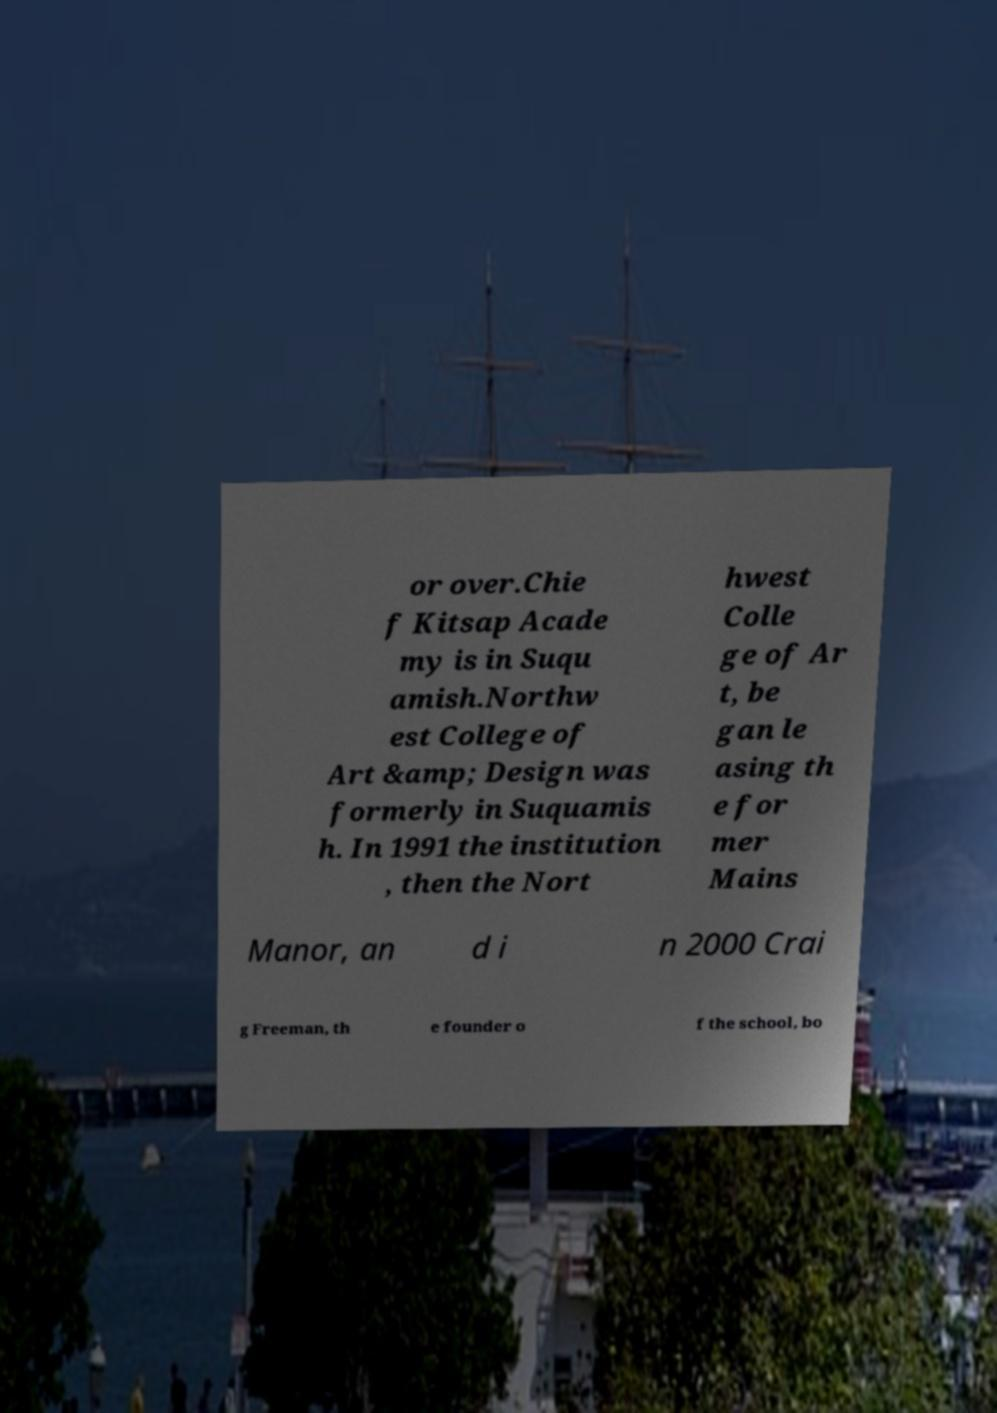Could you assist in decoding the text presented in this image and type it out clearly? or over.Chie f Kitsap Acade my is in Suqu amish.Northw est College of Art &amp; Design was formerly in Suquamis h. In 1991 the institution , then the Nort hwest Colle ge of Ar t, be gan le asing th e for mer Mains Manor, an d i n 2000 Crai g Freeman, th e founder o f the school, bo 